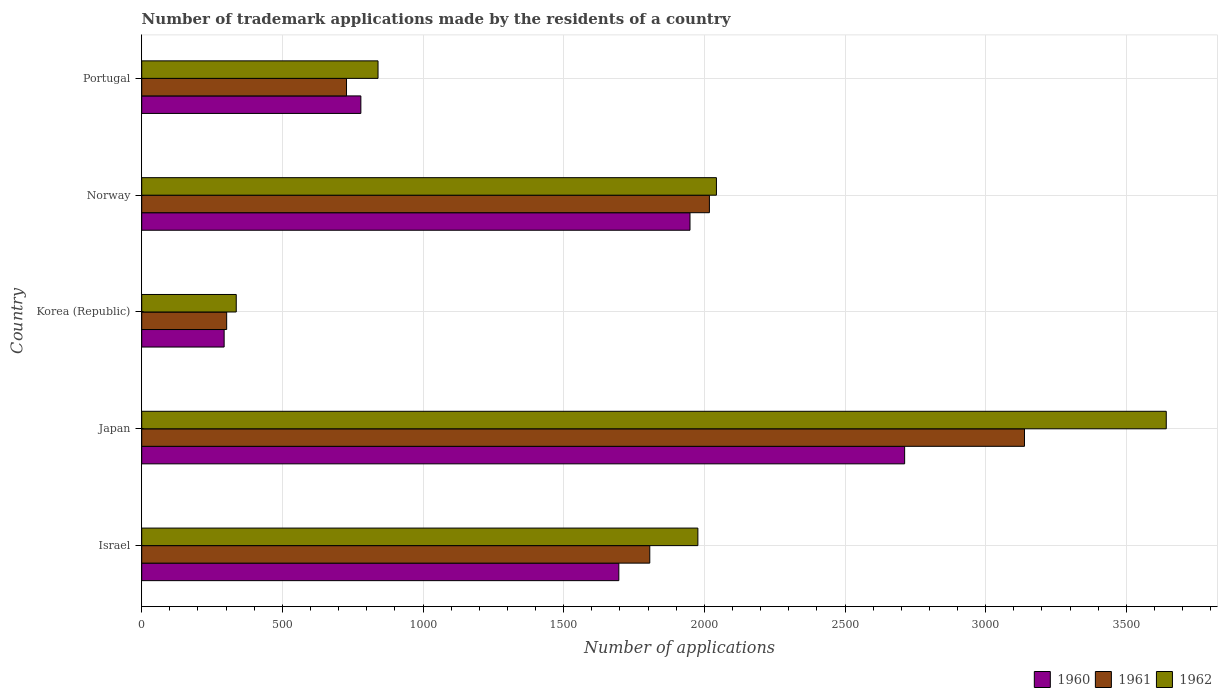How many different coloured bars are there?
Your answer should be very brief. 3. How many bars are there on the 5th tick from the bottom?
Ensure brevity in your answer.  3. What is the label of the 4th group of bars from the top?
Provide a succinct answer. Japan. What is the number of trademark applications made by the residents in 1962 in Japan?
Ensure brevity in your answer.  3642. Across all countries, what is the maximum number of trademark applications made by the residents in 1961?
Your answer should be very brief. 3138. Across all countries, what is the minimum number of trademark applications made by the residents in 1961?
Your response must be concise. 302. In which country was the number of trademark applications made by the residents in 1962 maximum?
Your answer should be compact. Japan. What is the total number of trademark applications made by the residents in 1961 in the graph?
Keep it short and to the point. 7992. What is the difference between the number of trademark applications made by the residents in 1962 in Norway and that in Portugal?
Provide a short and direct response. 1203. What is the difference between the number of trademark applications made by the residents in 1961 in Korea (Republic) and the number of trademark applications made by the residents in 1960 in Portugal?
Offer a terse response. -477. What is the average number of trademark applications made by the residents in 1961 per country?
Make the answer very short. 1598.4. What is the difference between the number of trademark applications made by the residents in 1961 and number of trademark applications made by the residents in 1962 in Norway?
Keep it short and to the point. -25. What is the ratio of the number of trademark applications made by the residents in 1961 in Korea (Republic) to that in Norway?
Offer a terse response. 0.15. Is the number of trademark applications made by the residents in 1962 in Japan less than that in Portugal?
Offer a very short reply. No. What is the difference between the highest and the second highest number of trademark applications made by the residents in 1960?
Ensure brevity in your answer.  763. What is the difference between the highest and the lowest number of trademark applications made by the residents in 1962?
Your answer should be compact. 3306. Is the sum of the number of trademark applications made by the residents in 1962 in Israel and Portugal greater than the maximum number of trademark applications made by the residents in 1961 across all countries?
Ensure brevity in your answer.  No. What does the 1st bar from the top in Israel represents?
Provide a short and direct response. 1962. Are all the bars in the graph horizontal?
Your answer should be very brief. Yes. How many countries are there in the graph?
Offer a very short reply. 5. What is the difference between two consecutive major ticks on the X-axis?
Your answer should be very brief. 500. What is the title of the graph?
Give a very brief answer. Number of trademark applications made by the residents of a country. What is the label or title of the X-axis?
Provide a short and direct response. Number of applications. What is the label or title of the Y-axis?
Give a very brief answer. Country. What is the Number of applications of 1960 in Israel?
Your answer should be compact. 1696. What is the Number of applications in 1961 in Israel?
Keep it short and to the point. 1806. What is the Number of applications in 1962 in Israel?
Provide a short and direct response. 1977. What is the Number of applications of 1960 in Japan?
Offer a very short reply. 2712. What is the Number of applications of 1961 in Japan?
Provide a succinct answer. 3138. What is the Number of applications of 1962 in Japan?
Your answer should be compact. 3642. What is the Number of applications in 1960 in Korea (Republic)?
Offer a terse response. 293. What is the Number of applications of 1961 in Korea (Republic)?
Your answer should be compact. 302. What is the Number of applications of 1962 in Korea (Republic)?
Your response must be concise. 336. What is the Number of applications in 1960 in Norway?
Keep it short and to the point. 1949. What is the Number of applications in 1961 in Norway?
Provide a succinct answer. 2018. What is the Number of applications of 1962 in Norway?
Keep it short and to the point. 2043. What is the Number of applications of 1960 in Portugal?
Ensure brevity in your answer.  779. What is the Number of applications in 1961 in Portugal?
Your answer should be compact. 728. What is the Number of applications in 1962 in Portugal?
Your answer should be very brief. 840. Across all countries, what is the maximum Number of applications in 1960?
Ensure brevity in your answer.  2712. Across all countries, what is the maximum Number of applications in 1961?
Your answer should be compact. 3138. Across all countries, what is the maximum Number of applications in 1962?
Provide a succinct answer. 3642. Across all countries, what is the minimum Number of applications of 1960?
Your answer should be compact. 293. Across all countries, what is the minimum Number of applications in 1961?
Your answer should be very brief. 302. Across all countries, what is the minimum Number of applications of 1962?
Your response must be concise. 336. What is the total Number of applications of 1960 in the graph?
Your answer should be compact. 7429. What is the total Number of applications of 1961 in the graph?
Keep it short and to the point. 7992. What is the total Number of applications in 1962 in the graph?
Offer a terse response. 8838. What is the difference between the Number of applications in 1960 in Israel and that in Japan?
Give a very brief answer. -1016. What is the difference between the Number of applications of 1961 in Israel and that in Japan?
Provide a short and direct response. -1332. What is the difference between the Number of applications in 1962 in Israel and that in Japan?
Keep it short and to the point. -1665. What is the difference between the Number of applications in 1960 in Israel and that in Korea (Republic)?
Keep it short and to the point. 1403. What is the difference between the Number of applications in 1961 in Israel and that in Korea (Republic)?
Make the answer very short. 1504. What is the difference between the Number of applications in 1962 in Israel and that in Korea (Republic)?
Make the answer very short. 1641. What is the difference between the Number of applications of 1960 in Israel and that in Norway?
Your response must be concise. -253. What is the difference between the Number of applications in 1961 in Israel and that in Norway?
Your answer should be compact. -212. What is the difference between the Number of applications of 1962 in Israel and that in Norway?
Make the answer very short. -66. What is the difference between the Number of applications in 1960 in Israel and that in Portugal?
Provide a short and direct response. 917. What is the difference between the Number of applications in 1961 in Israel and that in Portugal?
Ensure brevity in your answer.  1078. What is the difference between the Number of applications in 1962 in Israel and that in Portugal?
Your response must be concise. 1137. What is the difference between the Number of applications in 1960 in Japan and that in Korea (Republic)?
Give a very brief answer. 2419. What is the difference between the Number of applications of 1961 in Japan and that in Korea (Republic)?
Offer a very short reply. 2836. What is the difference between the Number of applications of 1962 in Japan and that in Korea (Republic)?
Give a very brief answer. 3306. What is the difference between the Number of applications of 1960 in Japan and that in Norway?
Provide a succinct answer. 763. What is the difference between the Number of applications in 1961 in Japan and that in Norway?
Your response must be concise. 1120. What is the difference between the Number of applications in 1962 in Japan and that in Norway?
Make the answer very short. 1599. What is the difference between the Number of applications in 1960 in Japan and that in Portugal?
Give a very brief answer. 1933. What is the difference between the Number of applications in 1961 in Japan and that in Portugal?
Make the answer very short. 2410. What is the difference between the Number of applications in 1962 in Japan and that in Portugal?
Make the answer very short. 2802. What is the difference between the Number of applications of 1960 in Korea (Republic) and that in Norway?
Your answer should be compact. -1656. What is the difference between the Number of applications of 1961 in Korea (Republic) and that in Norway?
Offer a very short reply. -1716. What is the difference between the Number of applications in 1962 in Korea (Republic) and that in Norway?
Ensure brevity in your answer.  -1707. What is the difference between the Number of applications in 1960 in Korea (Republic) and that in Portugal?
Offer a very short reply. -486. What is the difference between the Number of applications of 1961 in Korea (Republic) and that in Portugal?
Keep it short and to the point. -426. What is the difference between the Number of applications in 1962 in Korea (Republic) and that in Portugal?
Give a very brief answer. -504. What is the difference between the Number of applications of 1960 in Norway and that in Portugal?
Provide a short and direct response. 1170. What is the difference between the Number of applications in 1961 in Norway and that in Portugal?
Provide a short and direct response. 1290. What is the difference between the Number of applications in 1962 in Norway and that in Portugal?
Provide a succinct answer. 1203. What is the difference between the Number of applications in 1960 in Israel and the Number of applications in 1961 in Japan?
Keep it short and to the point. -1442. What is the difference between the Number of applications of 1960 in Israel and the Number of applications of 1962 in Japan?
Your answer should be very brief. -1946. What is the difference between the Number of applications in 1961 in Israel and the Number of applications in 1962 in Japan?
Your response must be concise. -1836. What is the difference between the Number of applications of 1960 in Israel and the Number of applications of 1961 in Korea (Republic)?
Provide a short and direct response. 1394. What is the difference between the Number of applications of 1960 in Israel and the Number of applications of 1962 in Korea (Republic)?
Your answer should be very brief. 1360. What is the difference between the Number of applications in 1961 in Israel and the Number of applications in 1962 in Korea (Republic)?
Offer a terse response. 1470. What is the difference between the Number of applications in 1960 in Israel and the Number of applications in 1961 in Norway?
Your answer should be compact. -322. What is the difference between the Number of applications in 1960 in Israel and the Number of applications in 1962 in Norway?
Provide a short and direct response. -347. What is the difference between the Number of applications in 1961 in Israel and the Number of applications in 1962 in Norway?
Offer a terse response. -237. What is the difference between the Number of applications in 1960 in Israel and the Number of applications in 1961 in Portugal?
Your answer should be very brief. 968. What is the difference between the Number of applications of 1960 in Israel and the Number of applications of 1962 in Portugal?
Provide a short and direct response. 856. What is the difference between the Number of applications of 1961 in Israel and the Number of applications of 1962 in Portugal?
Ensure brevity in your answer.  966. What is the difference between the Number of applications in 1960 in Japan and the Number of applications in 1961 in Korea (Republic)?
Keep it short and to the point. 2410. What is the difference between the Number of applications in 1960 in Japan and the Number of applications in 1962 in Korea (Republic)?
Ensure brevity in your answer.  2376. What is the difference between the Number of applications in 1961 in Japan and the Number of applications in 1962 in Korea (Republic)?
Keep it short and to the point. 2802. What is the difference between the Number of applications of 1960 in Japan and the Number of applications of 1961 in Norway?
Keep it short and to the point. 694. What is the difference between the Number of applications in 1960 in Japan and the Number of applications in 1962 in Norway?
Offer a very short reply. 669. What is the difference between the Number of applications of 1961 in Japan and the Number of applications of 1962 in Norway?
Keep it short and to the point. 1095. What is the difference between the Number of applications in 1960 in Japan and the Number of applications in 1961 in Portugal?
Your answer should be very brief. 1984. What is the difference between the Number of applications in 1960 in Japan and the Number of applications in 1962 in Portugal?
Make the answer very short. 1872. What is the difference between the Number of applications of 1961 in Japan and the Number of applications of 1962 in Portugal?
Keep it short and to the point. 2298. What is the difference between the Number of applications of 1960 in Korea (Republic) and the Number of applications of 1961 in Norway?
Your response must be concise. -1725. What is the difference between the Number of applications of 1960 in Korea (Republic) and the Number of applications of 1962 in Norway?
Keep it short and to the point. -1750. What is the difference between the Number of applications of 1961 in Korea (Republic) and the Number of applications of 1962 in Norway?
Give a very brief answer. -1741. What is the difference between the Number of applications of 1960 in Korea (Republic) and the Number of applications of 1961 in Portugal?
Keep it short and to the point. -435. What is the difference between the Number of applications in 1960 in Korea (Republic) and the Number of applications in 1962 in Portugal?
Provide a succinct answer. -547. What is the difference between the Number of applications in 1961 in Korea (Republic) and the Number of applications in 1962 in Portugal?
Provide a succinct answer. -538. What is the difference between the Number of applications in 1960 in Norway and the Number of applications in 1961 in Portugal?
Your answer should be very brief. 1221. What is the difference between the Number of applications in 1960 in Norway and the Number of applications in 1962 in Portugal?
Your answer should be very brief. 1109. What is the difference between the Number of applications in 1961 in Norway and the Number of applications in 1962 in Portugal?
Offer a very short reply. 1178. What is the average Number of applications in 1960 per country?
Keep it short and to the point. 1485.8. What is the average Number of applications in 1961 per country?
Keep it short and to the point. 1598.4. What is the average Number of applications in 1962 per country?
Offer a very short reply. 1767.6. What is the difference between the Number of applications of 1960 and Number of applications of 1961 in Israel?
Your response must be concise. -110. What is the difference between the Number of applications of 1960 and Number of applications of 1962 in Israel?
Your response must be concise. -281. What is the difference between the Number of applications in 1961 and Number of applications in 1962 in Israel?
Offer a very short reply. -171. What is the difference between the Number of applications in 1960 and Number of applications in 1961 in Japan?
Provide a succinct answer. -426. What is the difference between the Number of applications in 1960 and Number of applications in 1962 in Japan?
Your response must be concise. -930. What is the difference between the Number of applications of 1961 and Number of applications of 1962 in Japan?
Your answer should be very brief. -504. What is the difference between the Number of applications in 1960 and Number of applications in 1962 in Korea (Republic)?
Your answer should be very brief. -43. What is the difference between the Number of applications in 1961 and Number of applications in 1962 in Korea (Republic)?
Your response must be concise. -34. What is the difference between the Number of applications in 1960 and Number of applications in 1961 in Norway?
Offer a terse response. -69. What is the difference between the Number of applications of 1960 and Number of applications of 1962 in Norway?
Your answer should be very brief. -94. What is the difference between the Number of applications in 1960 and Number of applications in 1962 in Portugal?
Offer a terse response. -61. What is the difference between the Number of applications of 1961 and Number of applications of 1962 in Portugal?
Your answer should be very brief. -112. What is the ratio of the Number of applications of 1960 in Israel to that in Japan?
Ensure brevity in your answer.  0.63. What is the ratio of the Number of applications of 1961 in Israel to that in Japan?
Give a very brief answer. 0.58. What is the ratio of the Number of applications in 1962 in Israel to that in Japan?
Provide a succinct answer. 0.54. What is the ratio of the Number of applications in 1960 in Israel to that in Korea (Republic)?
Make the answer very short. 5.79. What is the ratio of the Number of applications in 1961 in Israel to that in Korea (Republic)?
Your answer should be compact. 5.98. What is the ratio of the Number of applications in 1962 in Israel to that in Korea (Republic)?
Your answer should be very brief. 5.88. What is the ratio of the Number of applications of 1960 in Israel to that in Norway?
Make the answer very short. 0.87. What is the ratio of the Number of applications in 1961 in Israel to that in Norway?
Offer a terse response. 0.89. What is the ratio of the Number of applications of 1960 in Israel to that in Portugal?
Your answer should be compact. 2.18. What is the ratio of the Number of applications in 1961 in Israel to that in Portugal?
Offer a very short reply. 2.48. What is the ratio of the Number of applications in 1962 in Israel to that in Portugal?
Ensure brevity in your answer.  2.35. What is the ratio of the Number of applications of 1960 in Japan to that in Korea (Republic)?
Keep it short and to the point. 9.26. What is the ratio of the Number of applications of 1961 in Japan to that in Korea (Republic)?
Make the answer very short. 10.39. What is the ratio of the Number of applications in 1962 in Japan to that in Korea (Republic)?
Keep it short and to the point. 10.84. What is the ratio of the Number of applications of 1960 in Japan to that in Norway?
Your answer should be compact. 1.39. What is the ratio of the Number of applications in 1961 in Japan to that in Norway?
Your response must be concise. 1.55. What is the ratio of the Number of applications in 1962 in Japan to that in Norway?
Offer a very short reply. 1.78. What is the ratio of the Number of applications in 1960 in Japan to that in Portugal?
Offer a very short reply. 3.48. What is the ratio of the Number of applications in 1961 in Japan to that in Portugal?
Ensure brevity in your answer.  4.31. What is the ratio of the Number of applications in 1962 in Japan to that in Portugal?
Provide a succinct answer. 4.34. What is the ratio of the Number of applications of 1960 in Korea (Republic) to that in Norway?
Make the answer very short. 0.15. What is the ratio of the Number of applications in 1961 in Korea (Republic) to that in Norway?
Ensure brevity in your answer.  0.15. What is the ratio of the Number of applications of 1962 in Korea (Republic) to that in Norway?
Keep it short and to the point. 0.16. What is the ratio of the Number of applications in 1960 in Korea (Republic) to that in Portugal?
Your response must be concise. 0.38. What is the ratio of the Number of applications in 1961 in Korea (Republic) to that in Portugal?
Offer a very short reply. 0.41. What is the ratio of the Number of applications in 1962 in Korea (Republic) to that in Portugal?
Your response must be concise. 0.4. What is the ratio of the Number of applications of 1960 in Norway to that in Portugal?
Give a very brief answer. 2.5. What is the ratio of the Number of applications in 1961 in Norway to that in Portugal?
Offer a terse response. 2.77. What is the ratio of the Number of applications in 1962 in Norway to that in Portugal?
Provide a short and direct response. 2.43. What is the difference between the highest and the second highest Number of applications of 1960?
Provide a short and direct response. 763. What is the difference between the highest and the second highest Number of applications of 1961?
Keep it short and to the point. 1120. What is the difference between the highest and the second highest Number of applications in 1962?
Provide a short and direct response. 1599. What is the difference between the highest and the lowest Number of applications in 1960?
Make the answer very short. 2419. What is the difference between the highest and the lowest Number of applications in 1961?
Keep it short and to the point. 2836. What is the difference between the highest and the lowest Number of applications of 1962?
Give a very brief answer. 3306. 